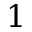Convert formula to latex. <formula><loc_0><loc_0><loc_500><loc_500>1</formula> 